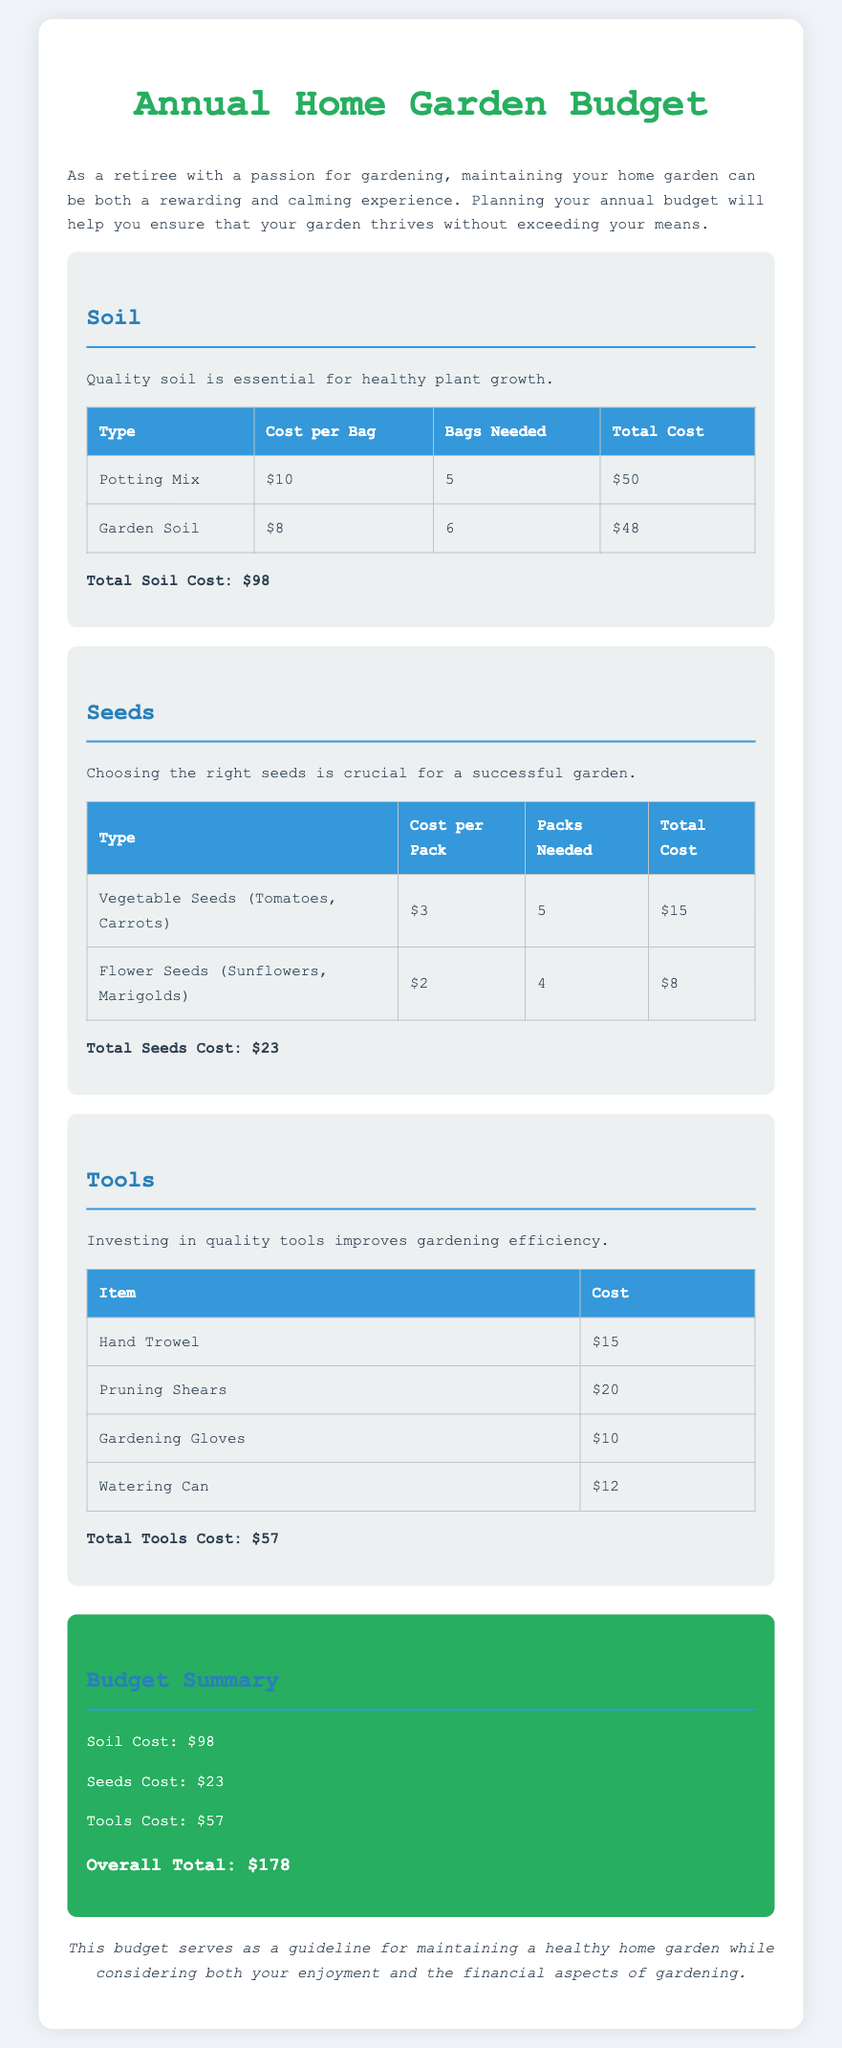what is the total soil cost? The total soil cost is provided as the sum of the individual soil expenses, which is $50 + $48.
Answer: $98 how much do vegetable seeds cost per pack? The cost per pack for vegetable seeds (Tomatoes, Carrots) is mentioned in the seeds category.
Answer: $3 how many packs of flower seeds are needed? The number of packs needed for flower seeds (Sunflowers, Marigolds) is specified in the seeds table.
Answer: 4 what is the total tools cost? The total tools cost is calculated as the sum of the individual tool prices, resulting in $15 + $20 + $10 + $12.
Answer: $57 what is the overall total budget? The overall total budget is the sum of soil, seeds, and tools costs presented in the budget summary, which totals $98 + $23 + $57.
Answer: $178 how much does a watering can cost? The cost of a watering can is listed in the tools section of the document.
Answer: $12 what type of seeds is included in the garden budget? The document specifies the types of seeds, highlighting both vegetable and flower seeds.
Answer: Vegetable and Flower Seeds how many bags of garden soil are needed? The number of bags needed for garden soil is indicated in the soil category of the document.
Answer: 6 what is the note about the budget meant to convey? The note summarizes the purpose of the budget as a guideline for maintaining a healthy home garden.
Answer: Guideline for maintaining a healthy home garden 